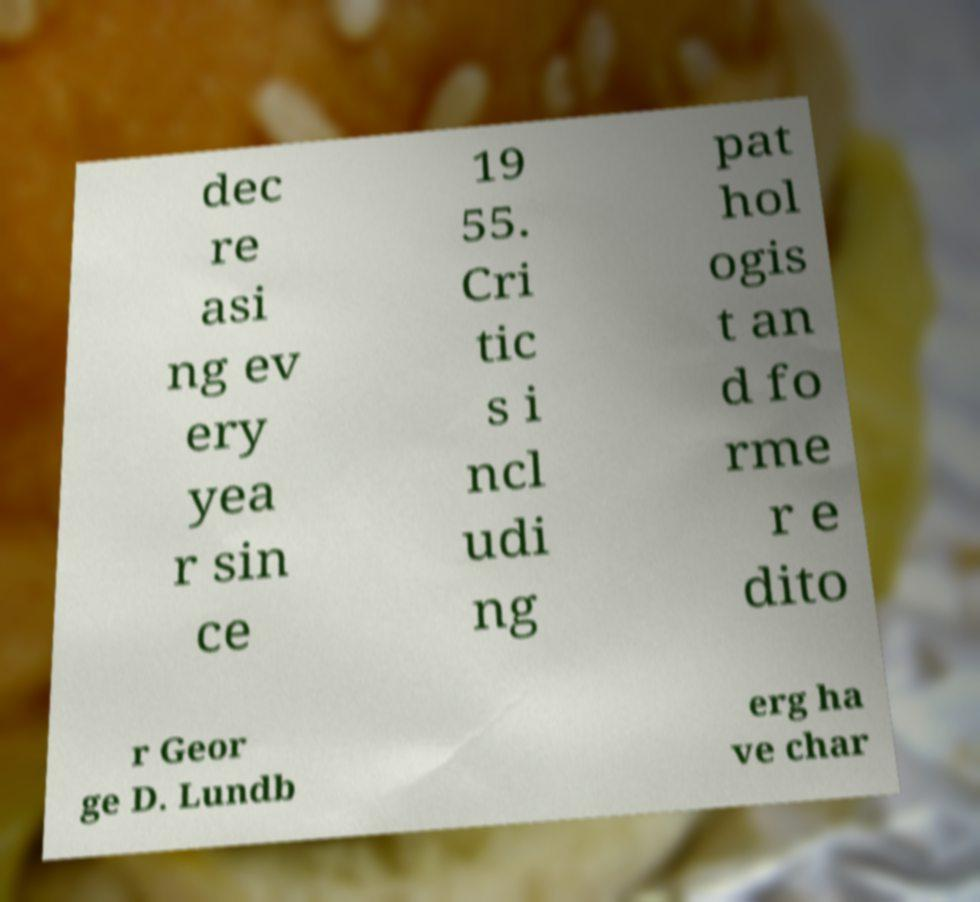Could you extract and type out the text from this image? dec re asi ng ev ery yea r sin ce 19 55. Cri tic s i ncl udi ng pat hol ogis t an d fo rme r e dito r Geor ge D. Lundb erg ha ve char 